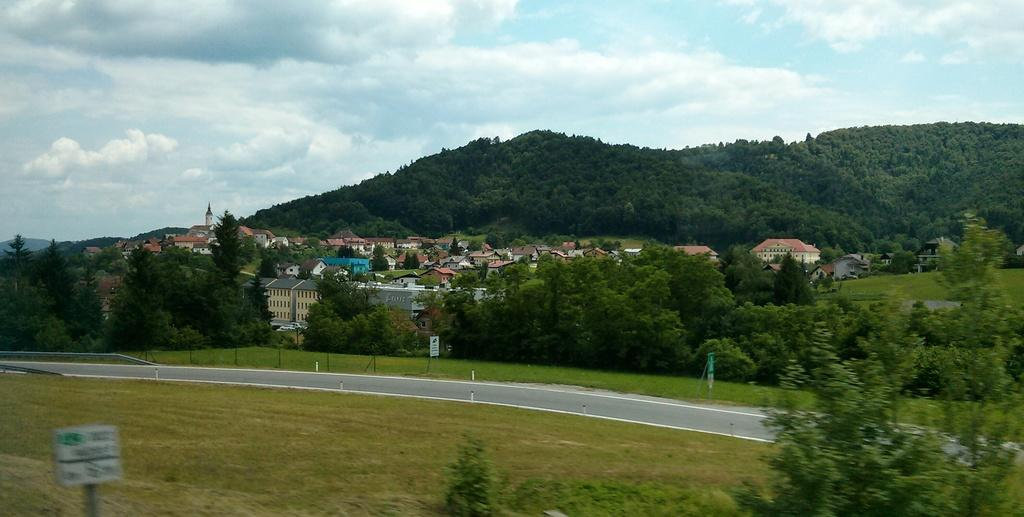What type of vegetation can be seen in the image? There are trees and plants in the image. What is the ground covered with in the image? There is grass in the image. What can be seen on the ground in the image? There are boards in the image. What type of man-made structure is visible in the image? There is a road in the image. What is visible in the background of the image? There are houses and the sky in the background of the image. How many steps can be seen leading up to the flight in the image? There are no steps or flights present in the image. What type of crack is visible on the road in the image? There is no crack visible on the road in the image. 